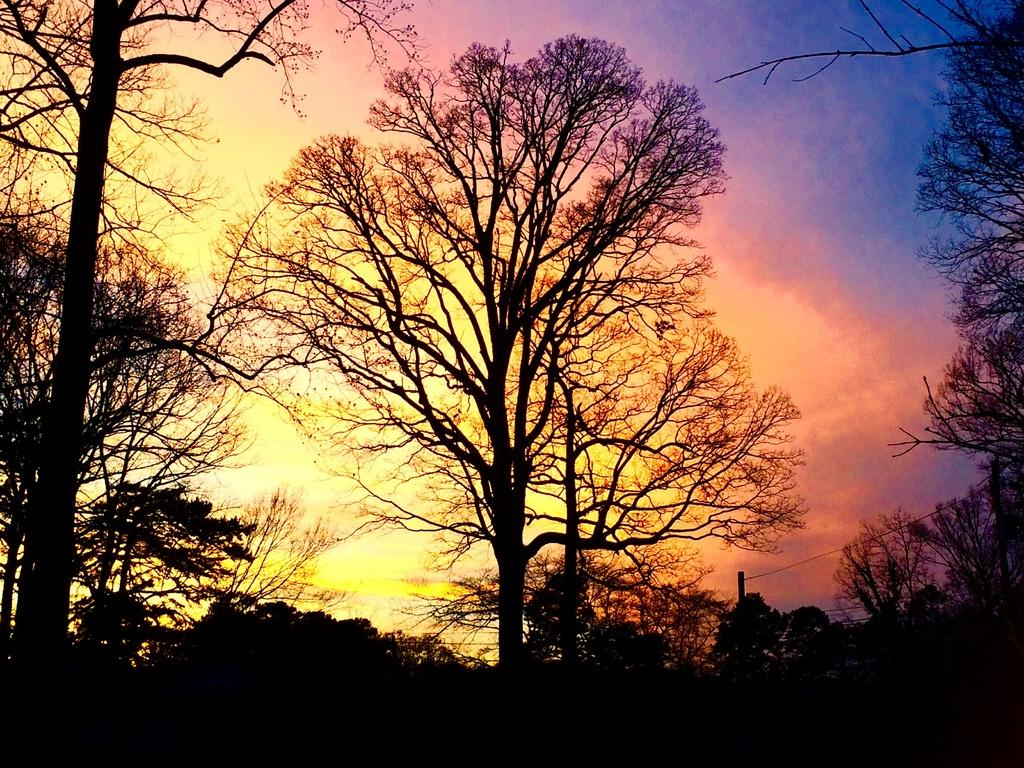What is the main feature of the image? There are a lot of trees in the image. What can be seen in the background of the image? The sky is visible in the background of the image. How would you describe the appearance of the sky? The sky is colorful in the image. What type of patch is sewn onto the trees in the image? There are no patches visible on the trees in the image. What type of grass is growing around the trees in the image? There is no grass visible around the trees in the image; it is focused on the trees and the sky. 